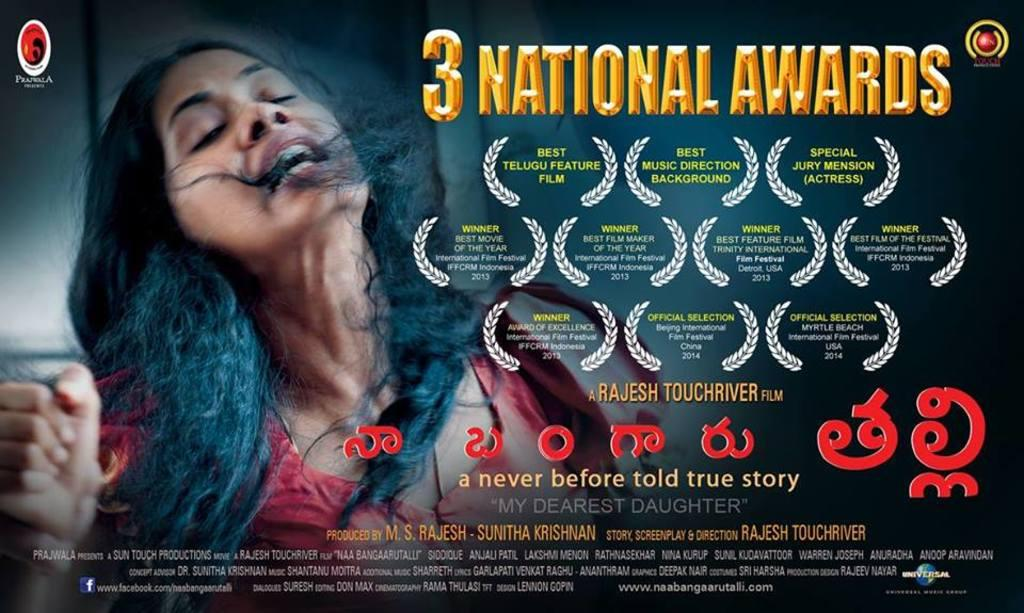<image>
Share a concise interpretation of the image provided. An advertisement for a movie that won 3 national awards 